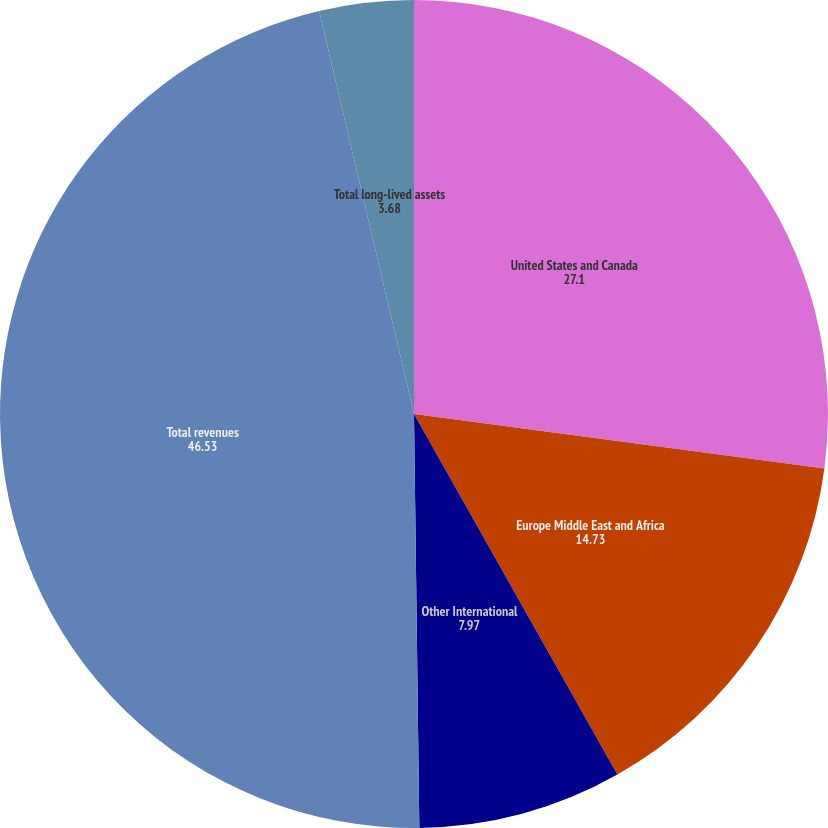Convert chart to OTSL. <chart><loc_0><loc_0><loc_500><loc_500><pie_chart><fcel>United States and Canada<fcel>Europe Middle East and Africa<fcel>Other International<fcel>Total revenues<fcel>Total long-lived assets<nl><fcel>27.1%<fcel>14.73%<fcel>7.97%<fcel>46.53%<fcel>3.68%<nl></chart> 